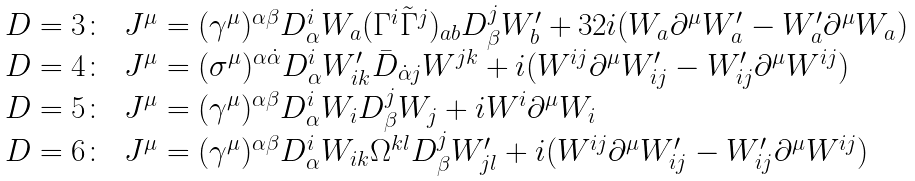<formula> <loc_0><loc_0><loc_500><loc_500>\begin{array} { l l } D = 3 \colon & J ^ { \mu } = ( \gamma ^ { \mu } ) ^ { \alpha \beta } D ^ { i } _ { \alpha } W _ { a } ( \Gamma ^ { i } \tilde { \Gamma } ^ { j } ) _ { a b } D ^ { j } _ { \beta } W ^ { \prime } _ { b } + 3 2 i ( W _ { a } \partial ^ { \mu } W ^ { \prime } _ { a } - W ^ { \prime } _ { a } \partial ^ { \mu } W _ { a } ) \\ D = 4 \colon & J ^ { \mu } = ( \sigma ^ { \mu } ) ^ { \alpha \dot { \alpha } } D ^ { i } _ { \alpha } W ^ { \prime } _ { i k } \bar { D } _ { \dot { \alpha } j } W ^ { j k } + i ( W ^ { i j } \partial ^ { \mu } W ^ { \prime } _ { i j } - W ^ { \prime } _ { i j } \partial ^ { \mu } W ^ { i j } ) \\ D = 5 \colon & J ^ { \mu } = ( \gamma ^ { \mu } ) ^ { \alpha \beta } D ^ { i } _ { \alpha } W _ { i } D ^ { j } _ { \beta } W _ { j } + i W ^ { i } \partial ^ { \mu } W _ { i } \\ D = 6 \colon & J ^ { \mu } = ( \gamma ^ { \mu } ) ^ { \alpha \beta } D ^ { i } _ { \alpha } W _ { i k } \Omega ^ { k l } D ^ { j } _ { \beta } W ^ { \prime } _ { j l } + i ( W ^ { i j } \partial ^ { \mu } W ^ { \prime } _ { i j } - W ^ { \prime } _ { i j } \partial ^ { \mu } W ^ { i j } ) \end{array}</formula> 